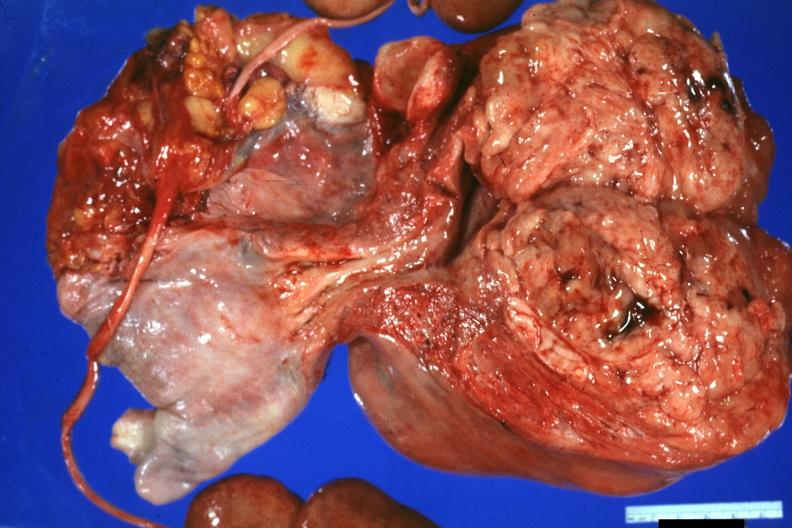s heart present?
Answer the question using a single word or phrase. No 